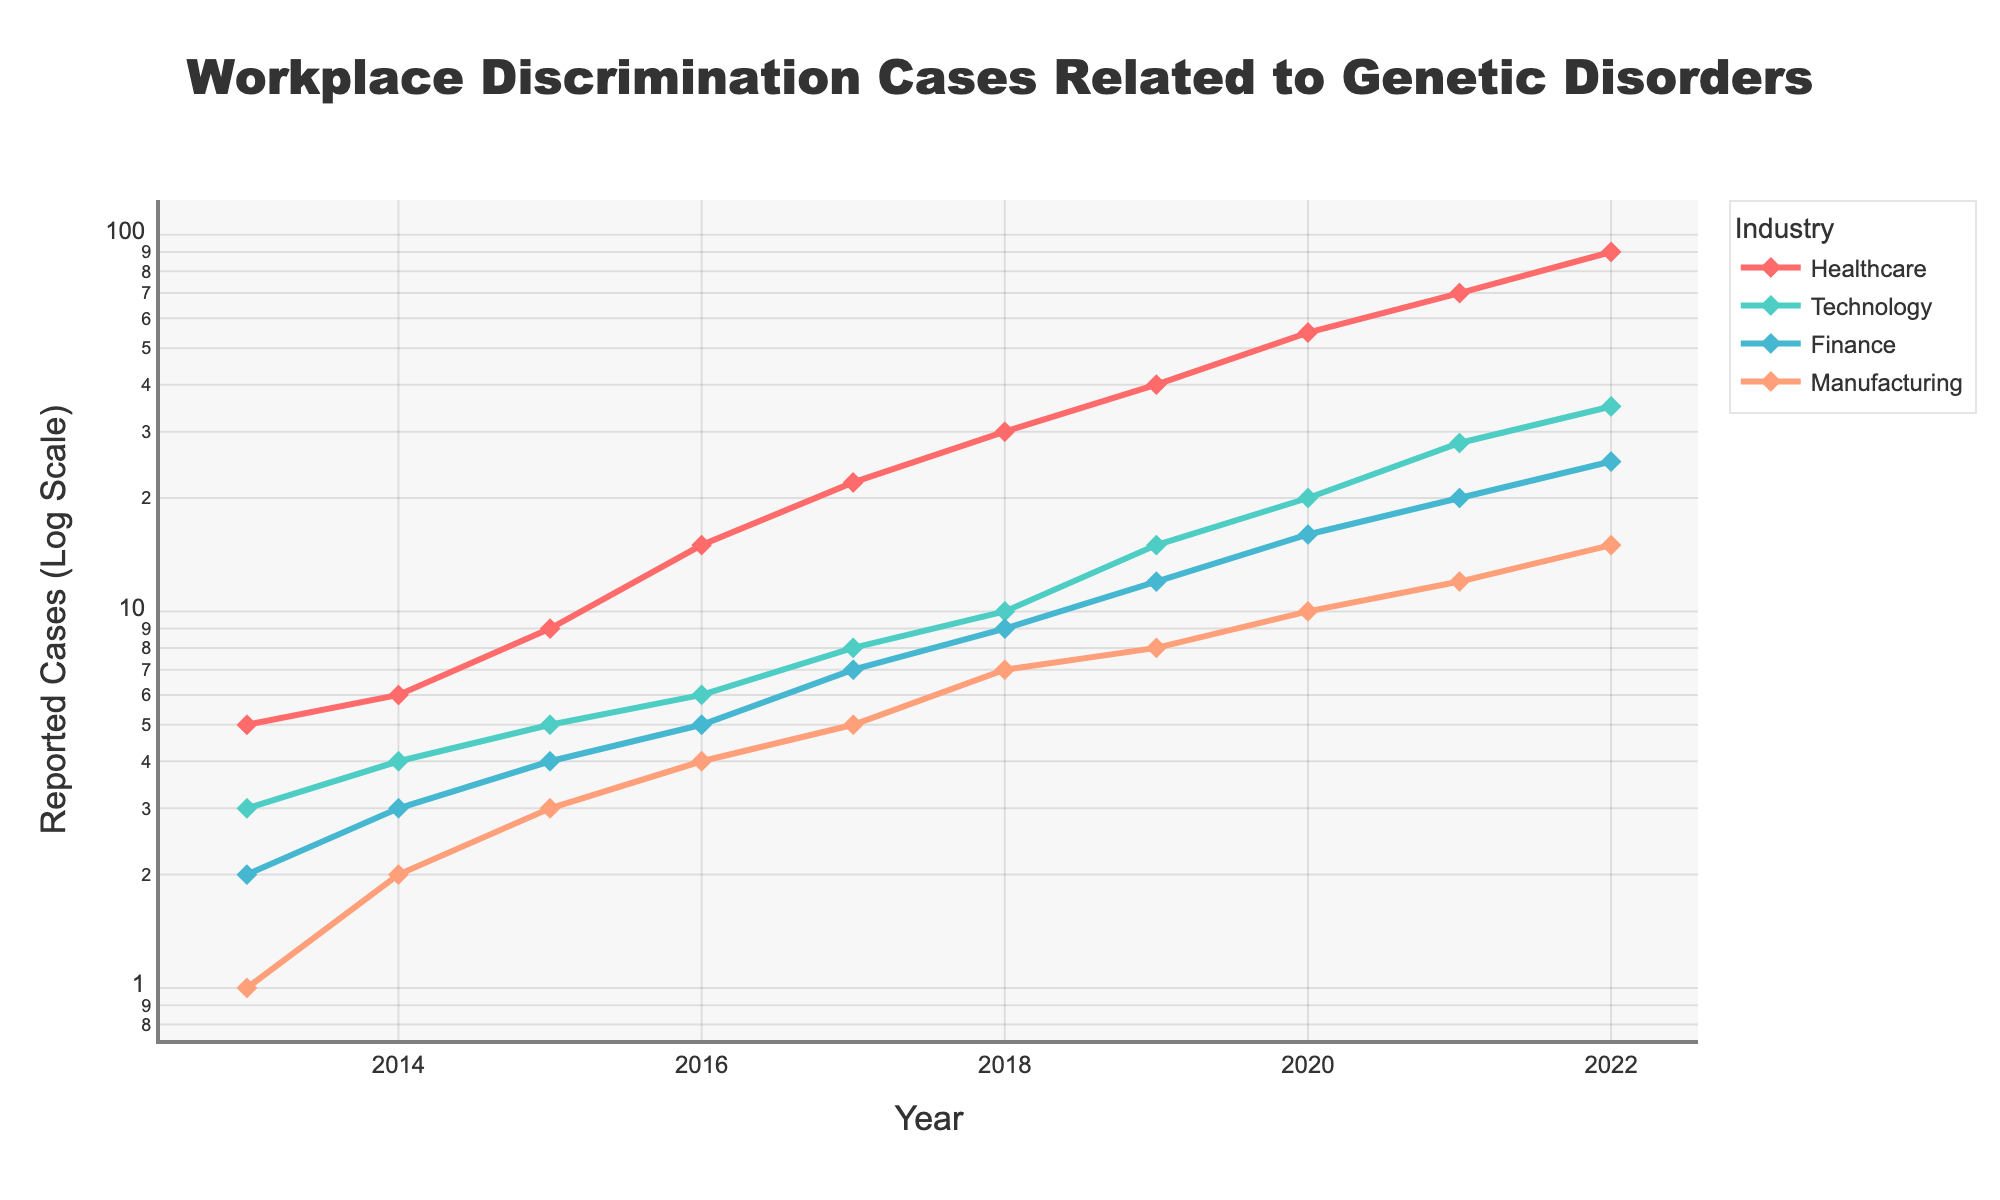What is the title of the figure? The title is located at the top of the figure and states the main subject of the plot.
Answer: Workplace Discrimination Cases Related to Genetic Disorders What color is used for the Technology industry line in the plot? The line color for each industry can be identified by looking at the legend on the plot.
Answer: #4ECDC4 How many reported cases were there in the Healthcare industry in 2022? Locate the line for Healthcare in the legend, follow it to the year 2022, and note the reported cases value.
Answer: 90 Between which years did the Technology industry see the largest increase in reported cases? Find the line for the Technology industry and observe the yearly points to determine where the largest upward jump occurs.
Answer: 2020 to 2021 What industries are represented in the figure? The industries can be identified by looking at the labels in the legend.
Answer: Healthcare, Technology, Finance, Manufacturing How many reported cases were there in total across all industries in 2020? Sum the reported cases from each line for the year 2020. Healthcare: 55, Technology: 20, Finance: 16, Manufacturing: 10. So, the total is 55 + 20 + 16 + 10 = 101.
Answer: 101 Which industry had the lowest number of reported cases in 2013? Compare the number of reported cases across all industries in the year 2013 and identify the smallest value.
Answer: Manufacturing Did any industry experience a decrease in reported cases over any year? Review the lines for each industry to check for any dips or downward trends.
Answer: No What is the range of reported cases for the Finance industry from 2013 to 2022? Find the minimum and maximum reported cases for the Finance industry over the given period. The range is then the difference between these two values, which is 25 - 2 = 23.
Answer: 23 How does the trend in the Manufacturing industry compare to the Finance industry from 2015 to 2021? The Manufacturing industry has a steadily increasing trend, while the Finance industry shows a slower growth rate compared to Manufacturing. Compare the growth pattern and magnitude of increase between these years.
Answer: Manufacturing saw a steadier increase 